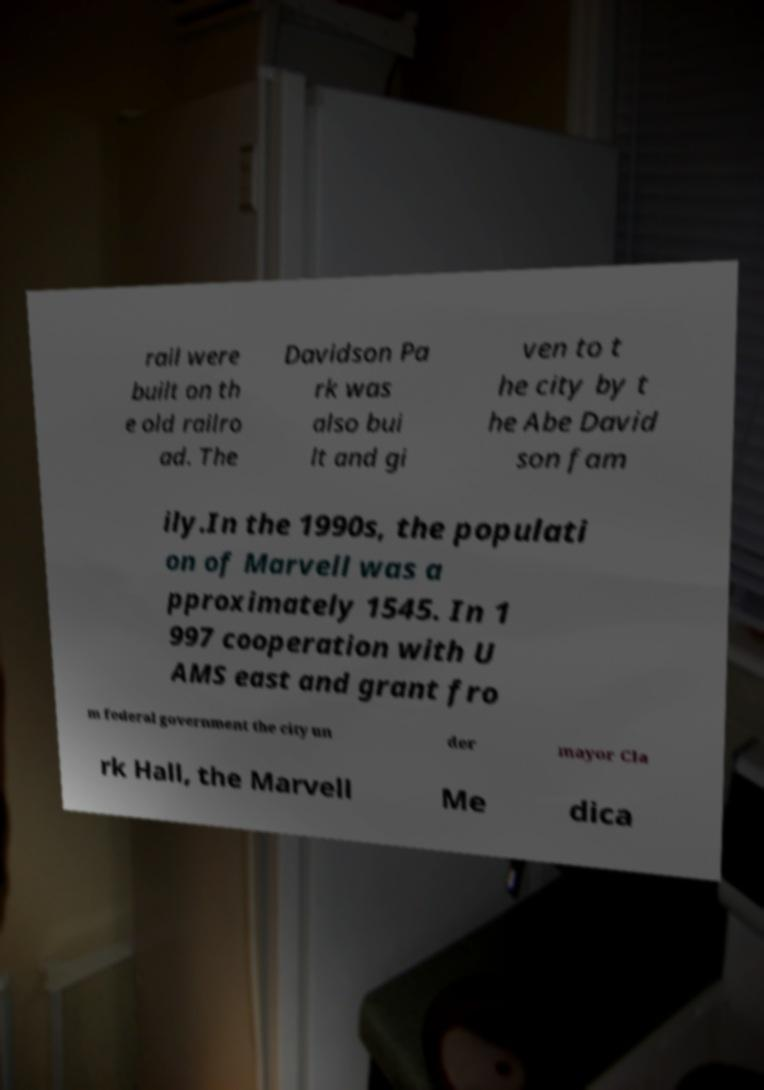Could you assist in decoding the text presented in this image and type it out clearly? rail were built on th e old railro ad. The Davidson Pa rk was also bui lt and gi ven to t he city by t he Abe David son fam ily.In the 1990s, the populati on of Marvell was a pproximately 1545. In 1 997 cooperation with U AMS east and grant fro m federal government the city un der mayor Cla rk Hall, the Marvell Me dica 